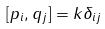<formula> <loc_0><loc_0><loc_500><loc_500>[ p _ { i } , q _ { j } ] = k \delta _ { i j }</formula> 